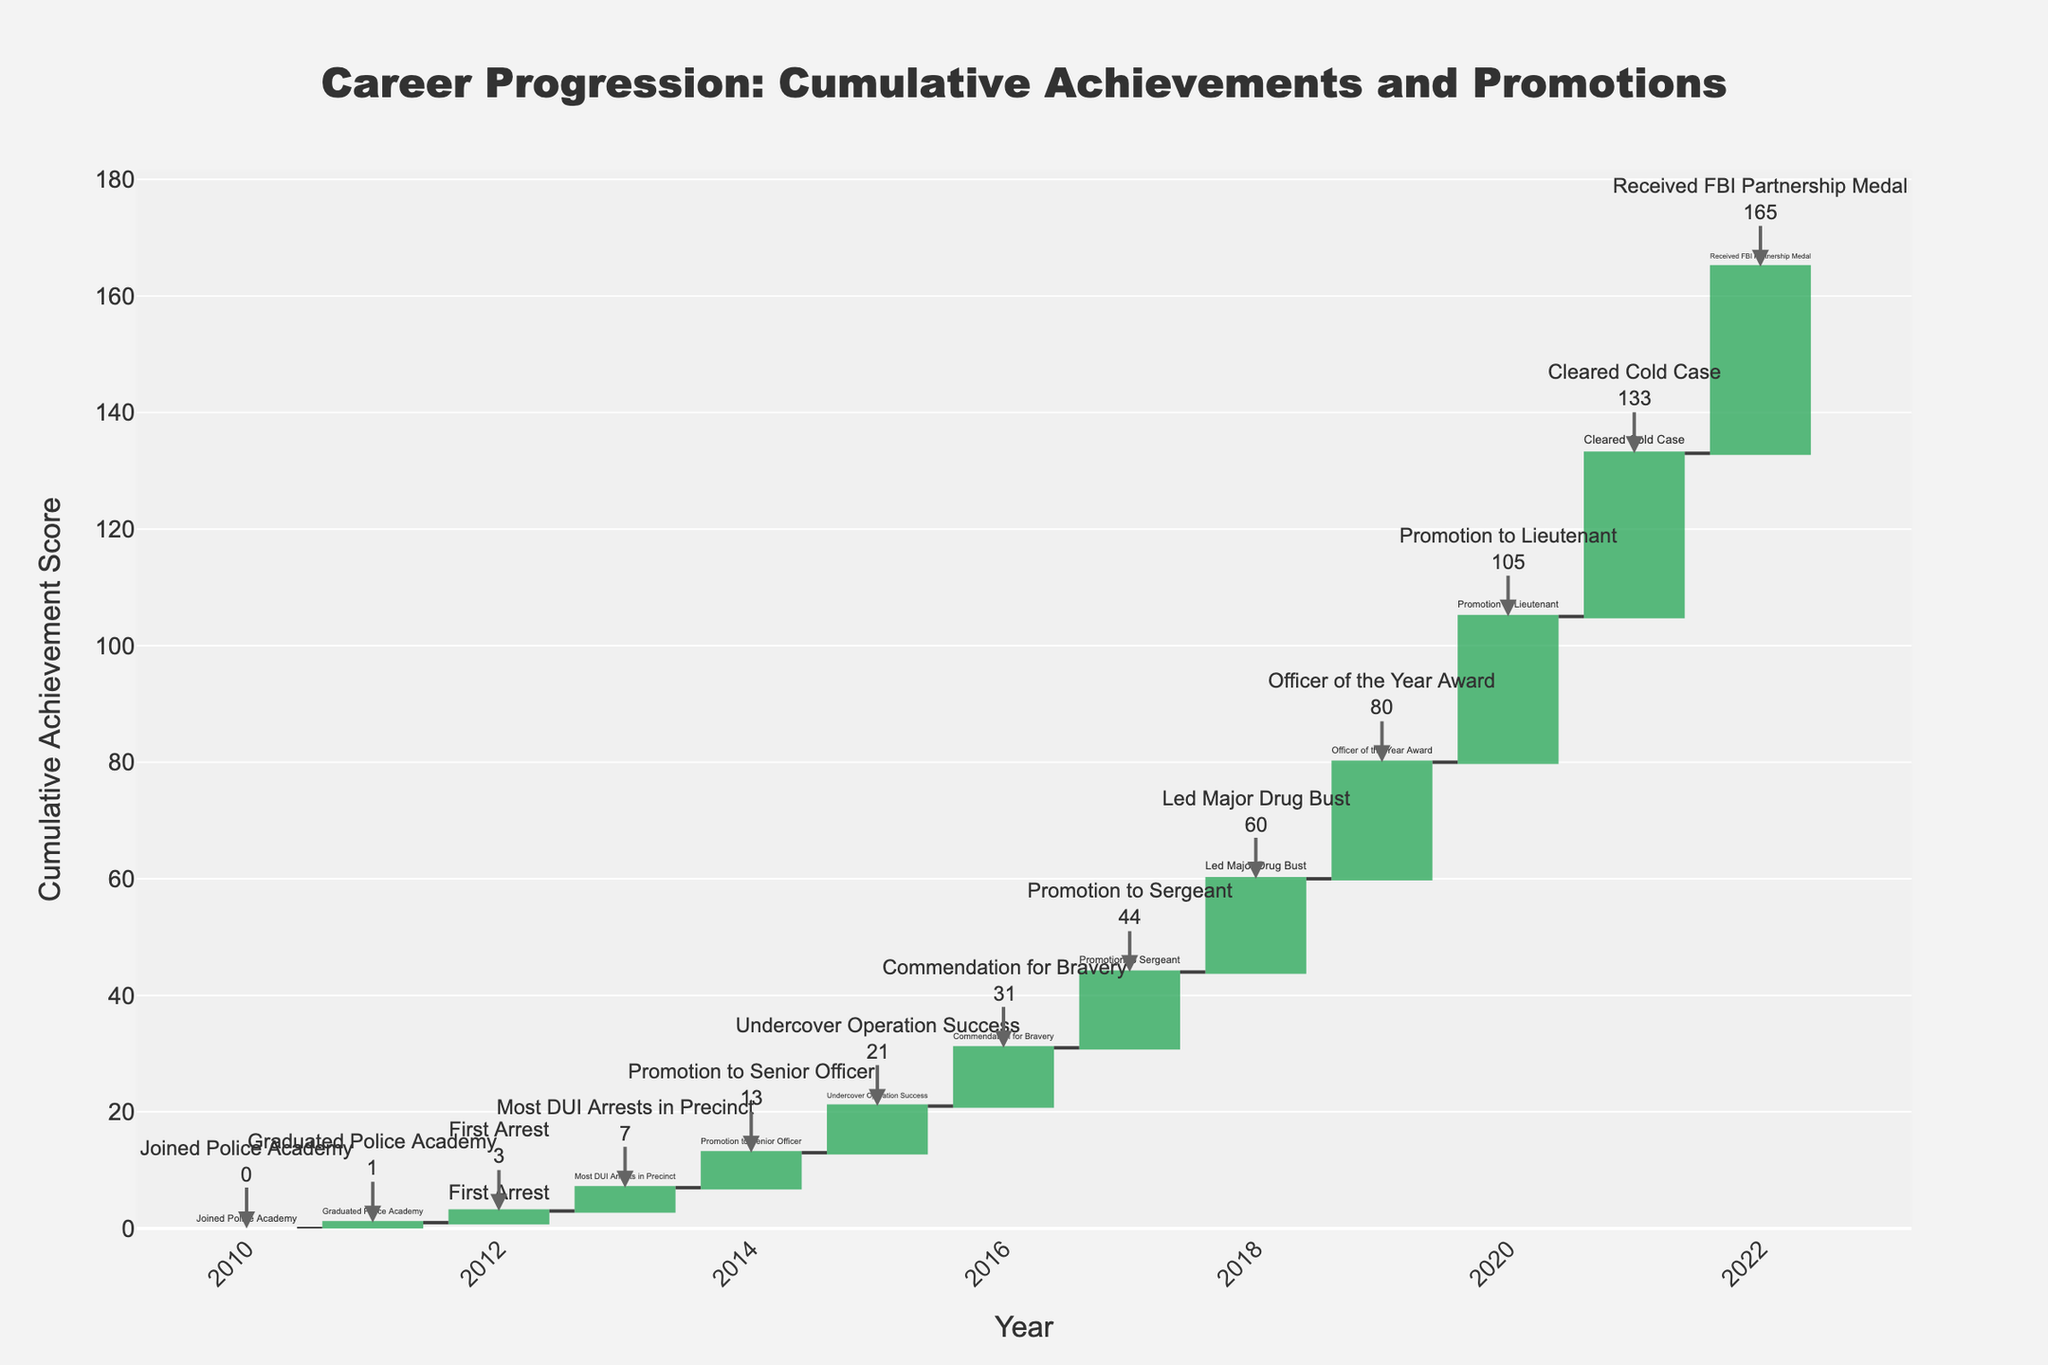What is the title of the figure? The title of the figure is clearly written at the top of the chart. It reads "Career Progression: Cumulative Achievements and Promotions"
Answer: Career Progression: Cumulative Achievements and Promotions What does the y-axis represent in this chart? The y-axis of the waterfall chart is labeled as "Cumulative Achievement Score," which means it shows the cumulative sum of achievements over the years.
Answer: Cumulative Achievement Score In which year was "Promotion to Senior Officer" achieved? By following the annotations and the x-axis, we can see that the "Promotion to Senior Officer" is achieved in the year 2014.
Answer: 2014 What is the cumulative achievement score after the "Officer of the Year Award"? According to the chart annotation for the "Officer of the Year Award," the cumulative achievement score after this event is 20.
Answer: 20 Which achievement contributed the most to the cumulative score increase and by how much? By looking at the height of the incremental bars, "Promotion to Lieutenant" in 2020 contributed the most with an increment of 5 to the cumulative score (from 20 to 25).
Answer: Promotion to Lieutenant, 5 What is the first achievement recorded on the chart? The first bar in the chart is labeled "Joined Police Academy" in the year 2010 with a zero-value start.
Answer: Joined Police Academy How many promotions are shown in this career progression pathway? By counting the occurrences of the word "Promotion" in the annotations, we find there are four promotions: to Senior Officer, Sergeant, Lieutenant, and another unspecified promotion.
Answer: 4 What is the cumulative achievement score in 2018 after leading a major drug bust? From the annotation and the chart label for 2018, the cumulative achievement score after "Led Major Drug Bust" is 16.
Answer: 16 Compare the cumulative achievement score from 2016 to 2020. By how much did it increase? In 2016, the score is noted as 10 for "Commendation for Bravery," and in 2020, it is 25 after "Promotion to Lieutenant." So, the increase is 25 - 10 = 15.
Answer: 15 What is the average cumulative achievement score from 2011 to 2015? From the annotations between these years: 1 (2011), 2 (2012), 4 (2013), 6 (2014), 8 (2015). Sum is 1+2+4+6+8 = 21. There are 5 years, so the average is 21/5 = 4.2.
Answer: 4.2 